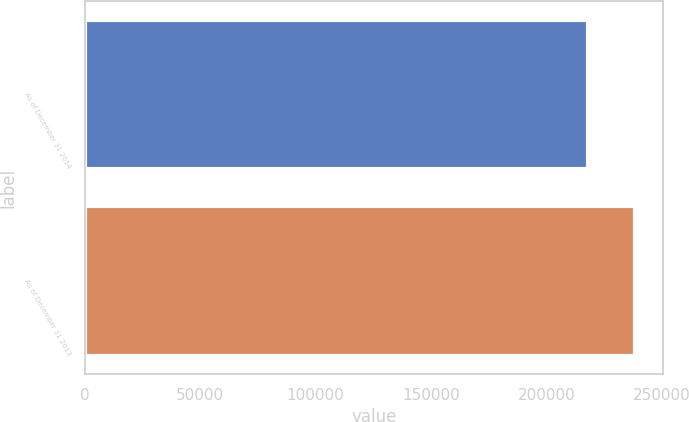Convert chart. <chart><loc_0><loc_0><loc_500><loc_500><bar_chart><fcel>As of December 31 2014<fcel>As of December 31 2013<nl><fcel>218168<fcel>238604<nl></chart> 